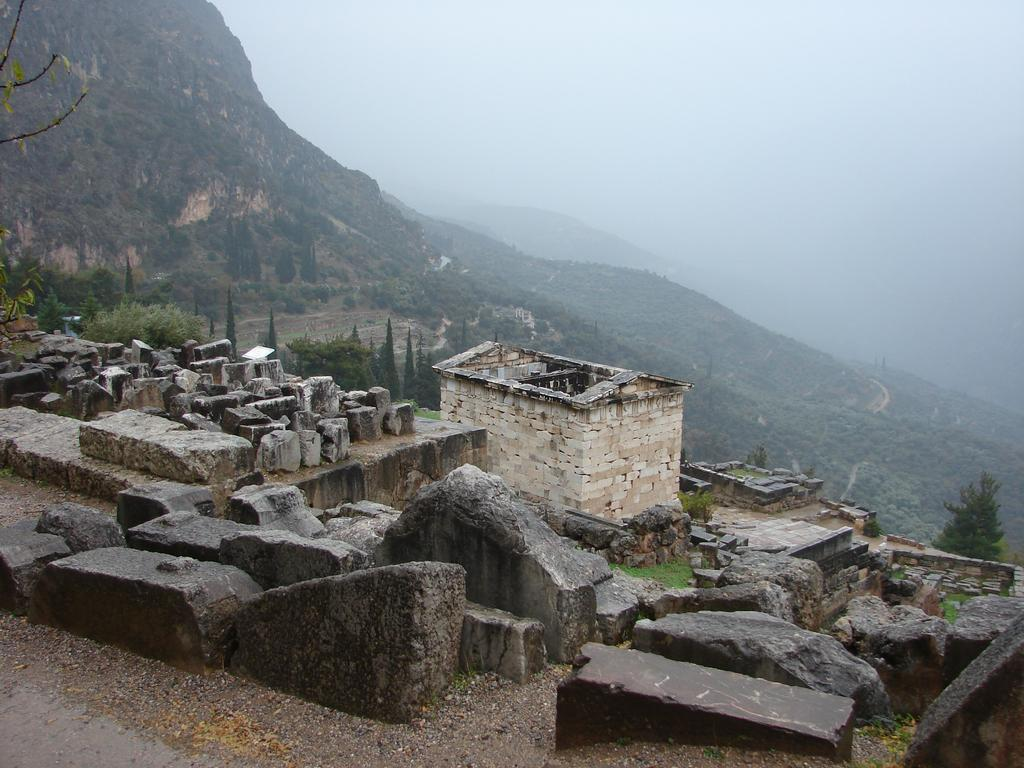What can be found in the foreground area of the image? There are stones and a house structure in the foreground area. What type of vegetation or plants can be seen in the image? There is greenery in the image. What is visible in the background of the image? Mountains, smoke, and the sky are visible in the background. Can you hear the kitten singing songs in the image? There is no kitten or any indication of singing in the image. Is there a goat visible in the image? No, there is no goat present in the image. 